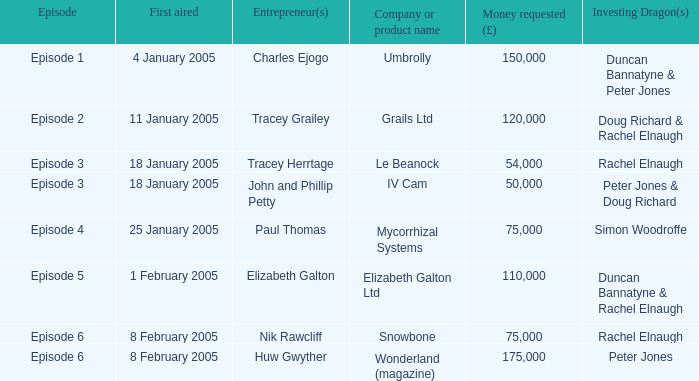Who were the Investing Dragons in the episode that first aired on 18 January 2005 with the entrepreneur Tracey Herrtage? Rachel Elnaugh. 